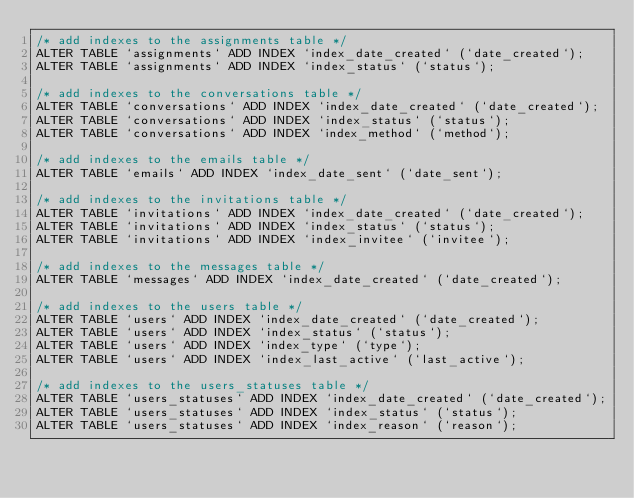Convert code to text. <code><loc_0><loc_0><loc_500><loc_500><_SQL_>/* add indexes to the assignments table */
ALTER TABLE `assignments` ADD INDEX `index_date_created` (`date_created`);
ALTER TABLE `assignments` ADD INDEX `index_status` (`status`);

/* add indexes to the conversations table */
ALTER TABLE `conversations` ADD INDEX `index_date_created` (`date_created`);
ALTER TABLE `conversations` ADD INDEX `index_status` (`status`);
ALTER TABLE `conversations` ADD INDEX `index_method` (`method`);

/* add indexes to the emails table */
ALTER TABLE `emails` ADD INDEX `index_date_sent` (`date_sent`);

/* add indexes to the invitations table */
ALTER TABLE `invitations` ADD INDEX `index_date_created` (`date_created`);
ALTER TABLE `invitations` ADD INDEX `index_status` (`status`);
ALTER TABLE `invitations` ADD INDEX `index_invitee` (`invitee`);

/* add indexes to the messages table */
ALTER TABLE `messages` ADD INDEX `index_date_created` (`date_created`);

/* add indexes to the users table */
ALTER TABLE `users` ADD INDEX `index_date_created` (`date_created`);
ALTER TABLE `users` ADD INDEX `index_status` (`status`);
ALTER TABLE `users` ADD INDEX `index_type` (`type`);
ALTER TABLE `users` ADD INDEX `index_last_active` (`last_active`);

/* add indexes to the users_statuses table */
ALTER TABLE `users_statuses` ADD INDEX `index_date_created` (`date_created`);
ALTER TABLE `users_statuses` ADD INDEX `index_status` (`status`);
ALTER TABLE `users_statuses` ADD INDEX `index_reason` (`reason`);
</code> 